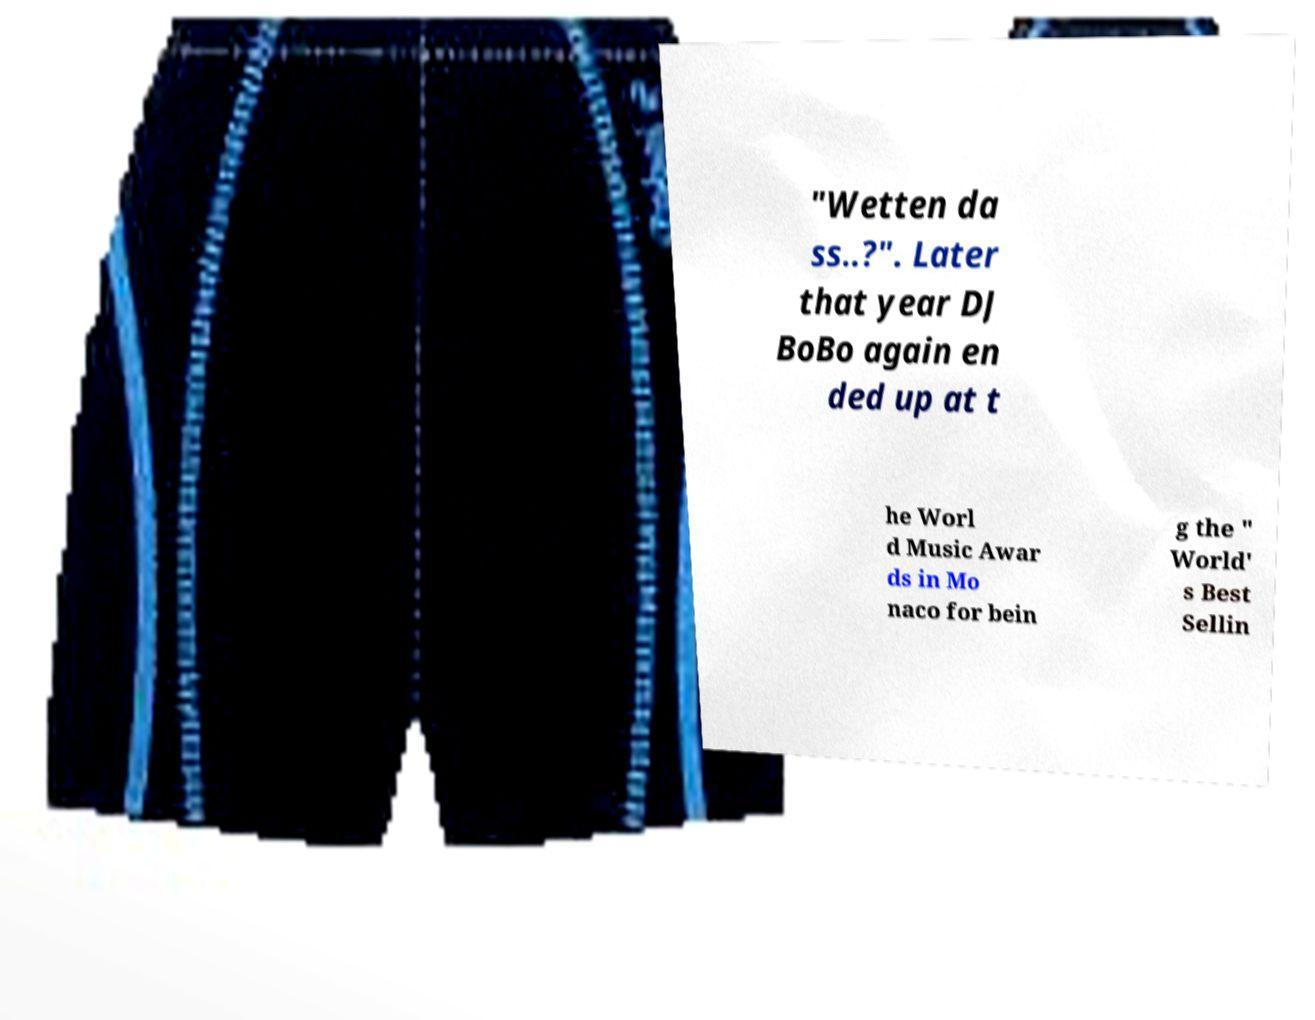For documentation purposes, I need the text within this image transcribed. Could you provide that? "Wetten da ss..?". Later that year DJ BoBo again en ded up at t he Worl d Music Awar ds in Mo naco for bein g the " World' s Best Sellin 